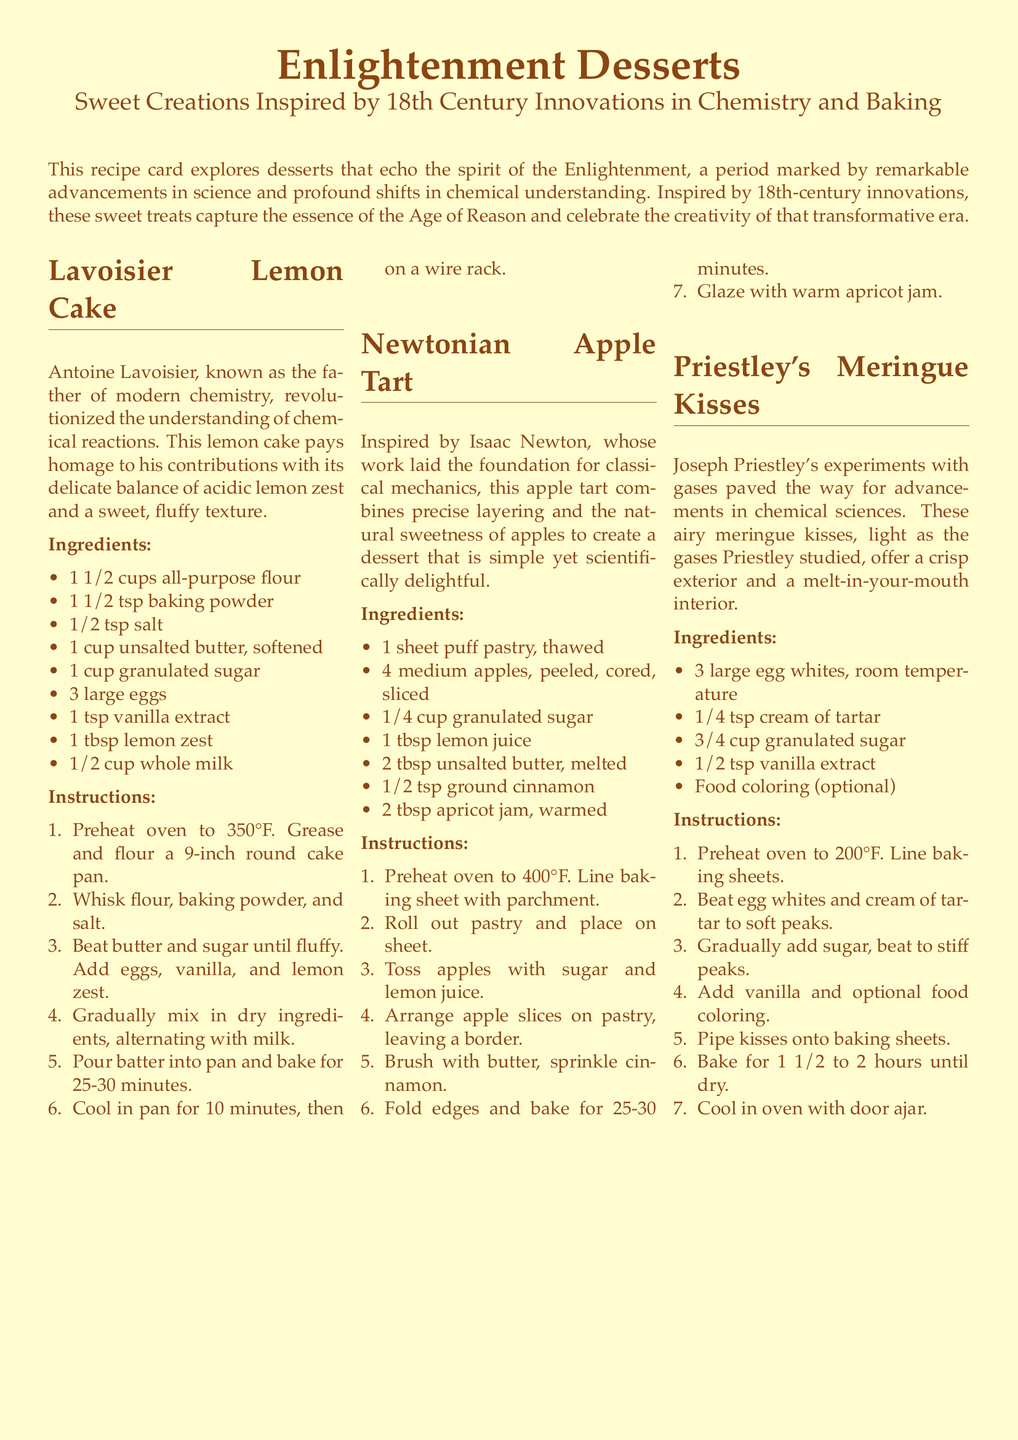What is the title of the dessert inspired by Lavoisier? The title of the dessert is found in the first section, highlighting Lavoisier's contributions to chemistry.
Answer: Lavoisier Lemon Cake How many eggs are needed for the Lavoisier Lemon Cake? The number of eggs is specified in the ingredients list for the lemon cake section.
Answer: 3 What is the baking temperature for the Newtonian Apple Tart? The baking temperature is clearly stated in the instructions for the apple tart preparation.
Answer: 400°F What is the total number of ingredients listed for Priestley's Meringue Kisses? The total ingredients can be counted from the list provided in the meringue kisses section.
Answer: 5 Which gas experiments are attributed to Joseph Priestley? The document points to the connection between Priestley's experiments and his subsequent advancements in chemical sciences.
Answer: Gases What is the main fruit used in the Newtonian Apple Tart? The main fruit is mentioned in the description of the tart.
Answer: Apples What color is the background of the recipe card? The background color is specified in the document styling.
Answer: Cream How long should the meringue kisses bake? The baking duration is detailed in the instructions section for the meringue kisses.
Answer: 1 1/2 to 2 hours 